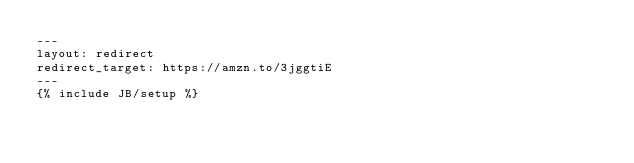Convert code to text. <code><loc_0><loc_0><loc_500><loc_500><_HTML_>---
layout: redirect
redirect_target: https://amzn.to/3jggtiE
---
{% include JB/setup %}</code> 